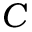Convert formula to latex. <formula><loc_0><loc_0><loc_500><loc_500>C</formula> 